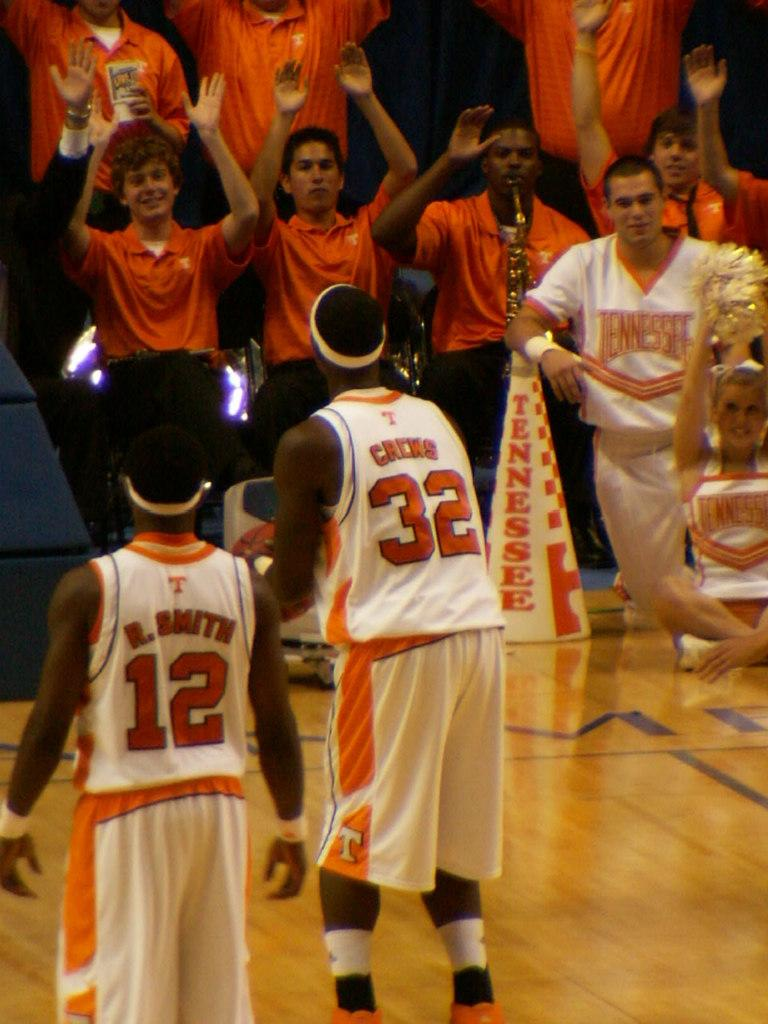<image>
Provide a brief description of the given image. The player with the ball is wearing number 32 